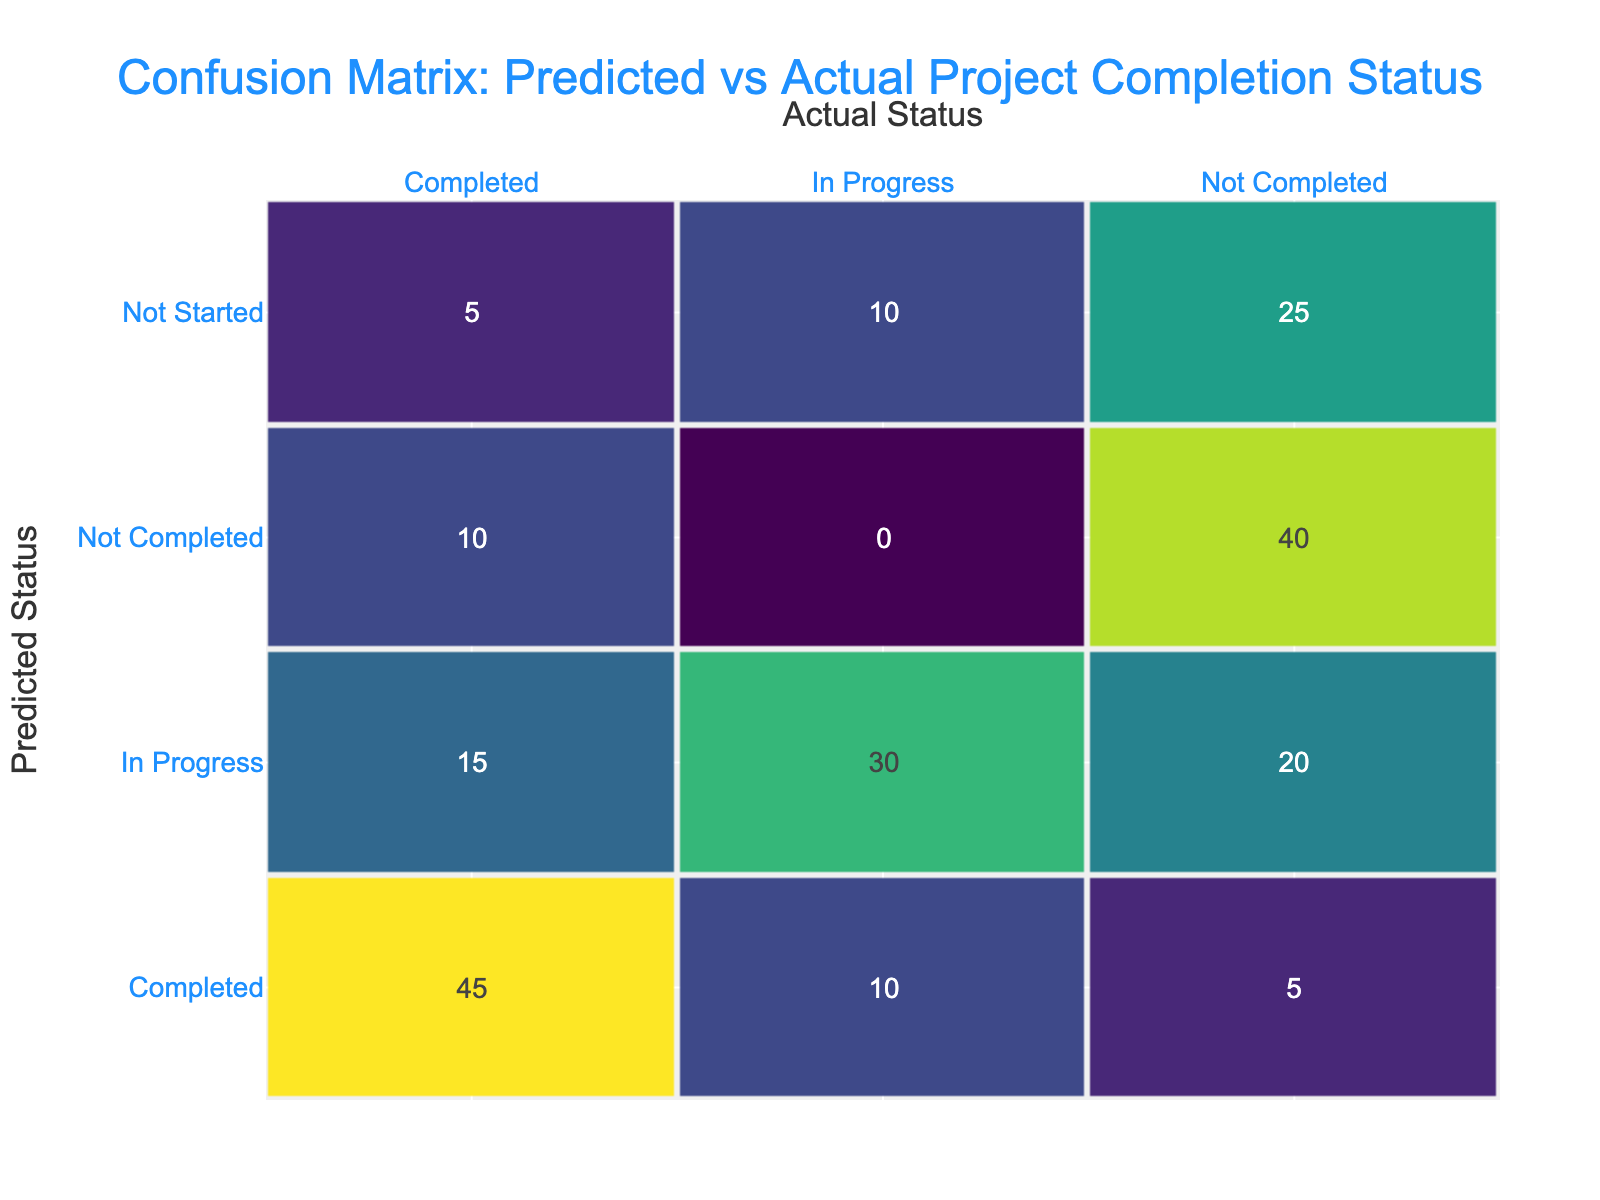What is the count of projects that were correctly predicted as completed? In the table, the predicted status 'Completed' corresponds to the actual status 'Completed' with a count of 45. Thus, this value can be directly retrieved from the table.
Answer: 45 How many projects were actually completed but predicted as not completed? Looking at the predicted status 'Not Completed' and the actual status 'Completed', there are 10 projects that fit this category. This can be found directly in the table.
Answer: 10 What is the total number of projects predicted as 'In Progress'? To find the total predicted as 'In Progress', we sum the counts for all rows where the predicted status is 'In Progress': 15 (completed) + 20 (not completed) + 30 (in progress) + 10 (not started) = 75.
Answer: 75 Is there any project that was predicted as 'Not Started' and actually completed? Referring to the row where the predicted status is 'Not Started' and actual status is 'Completed', we see a count of 5. This indicates that there were projects fitting this description.
Answer: Yes What is the difference between the number of projects predicted as 'Completed' and those predicted as 'Not Completed'? For 'Completed', we have an actual total of 45 plus 5 (not completed), which gives us 50 projects. For 'Not Completed', we add up 10 (completed) and 40 (not completed), totalling 50 as well. The difference is 50 - 50 = 0.
Answer: 0 What proportion of projects predicted as 'In Progress' were actually completed? There are 15 projects that were predicted as 'In Progress' and actually completed. The total number of projects predicted as 'In Progress' is 15 + 20 + 30 + 10 = 75. The proportion is 15/75 = 0.2 or 20%.
Answer: 20% How many projects were predicted as 'Completed' but actually in progress? By looking at the row for predicted status 'Completed' with the actual status 'In Progress', we find a count of 10. This value can be directly identified in the table.
Answer: 10 What is the average number of projects for each predicted status? We can calculate the average by summing all counts and then dividing by the number of unique predicted statuses. The total count is 5 + 15 + 45 + 40 + 10 + 20 + 30 + 10 + 5 + 25 + 10 = 215. There are 7 unique predicted statuses (Completed, Not Completed, In Progress, Not Started). The average is 215 / 7 ≈ 30.71.
Answer: 30.71 How many projects actually were not completed but predicted as 'In Progress'? For the category of predicted status 'In Progress' and actual status 'Not Completed', we find a count of 20. This data point is available in the confusion matrix.
Answer: 20 